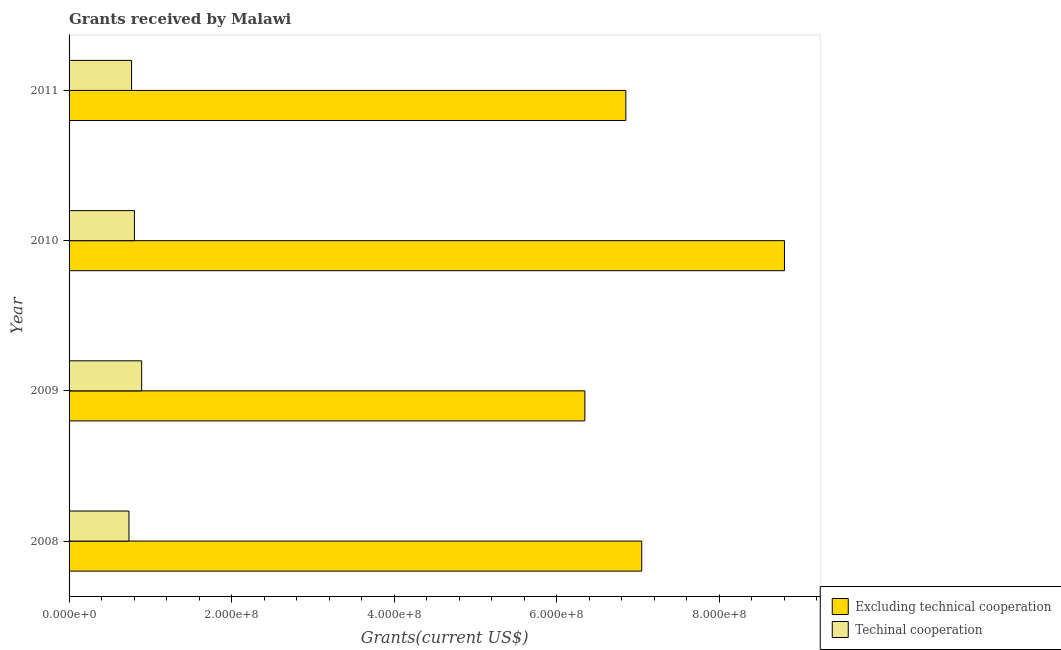How many different coloured bars are there?
Offer a very short reply. 2. How many groups of bars are there?
Keep it short and to the point. 4. Are the number of bars per tick equal to the number of legend labels?
Offer a very short reply. Yes. Are the number of bars on each tick of the Y-axis equal?
Your answer should be compact. Yes. What is the amount of grants received(excluding technical cooperation) in 2010?
Your answer should be compact. 8.80e+08. Across all years, what is the maximum amount of grants received(excluding technical cooperation)?
Your answer should be compact. 8.80e+08. Across all years, what is the minimum amount of grants received(excluding technical cooperation)?
Your response must be concise. 6.35e+08. In which year was the amount of grants received(excluding technical cooperation) maximum?
Provide a succinct answer. 2010. What is the total amount of grants received(including technical cooperation) in the graph?
Your answer should be compact. 3.20e+08. What is the difference between the amount of grants received(including technical cooperation) in 2009 and that in 2011?
Your answer should be very brief. 1.24e+07. What is the difference between the amount of grants received(excluding technical cooperation) in 2008 and the amount of grants received(including technical cooperation) in 2011?
Provide a short and direct response. 6.28e+08. What is the average amount of grants received(including technical cooperation) per year?
Give a very brief answer. 8.01e+07. In the year 2010, what is the difference between the amount of grants received(excluding technical cooperation) and amount of grants received(including technical cooperation)?
Make the answer very short. 8.00e+08. What is the ratio of the amount of grants received(including technical cooperation) in 2008 to that in 2011?
Your answer should be compact. 0.96. Is the amount of grants received(including technical cooperation) in 2008 less than that in 2010?
Provide a succinct answer. Yes. Is the difference between the amount of grants received(excluding technical cooperation) in 2010 and 2011 greater than the difference between the amount of grants received(including technical cooperation) in 2010 and 2011?
Your answer should be compact. Yes. What is the difference between the highest and the second highest amount of grants received(including technical cooperation)?
Your answer should be very brief. 8.90e+06. What is the difference between the highest and the lowest amount of grants received(including technical cooperation)?
Your answer should be very brief. 1.56e+07. Is the sum of the amount of grants received(excluding technical cooperation) in 2008 and 2010 greater than the maximum amount of grants received(including technical cooperation) across all years?
Ensure brevity in your answer.  Yes. What does the 1st bar from the top in 2011 represents?
Make the answer very short. Techinal cooperation. What does the 1st bar from the bottom in 2011 represents?
Provide a succinct answer. Excluding technical cooperation. Are all the bars in the graph horizontal?
Keep it short and to the point. Yes. Are the values on the major ticks of X-axis written in scientific E-notation?
Your answer should be very brief. Yes. Does the graph contain any zero values?
Offer a terse response. No. Where does the legend appear in the graph?
Make the answer very short. Bottom right. How many legend labels are there?
Give a very brief answer. 2. What is the title of the graph?
Keep it short and to the point. Grants received by Malawi. Does "Nitrous oxide emissions" appear as one of the legend labels in the graph?
Offer a terse response. No. What is the label or title of the X-axis?
Offer a very short reply. Grants(current US$). What is the Grants(current US$) of Excluding technical cooperation in 2008?
Ensure brevity in your answer.  7.05e+08. What is the Grants(current US$) in Techinal cooperation in 2008?
Provide a succinct answer. 7.37e+07. What is the Grants(current US$) in Excluding technical cooperation in 2009?
Provide a succinct answer. 6.35e+08. What is the Grants(current US$) in Techinal cooperation in 2009?
Offer a terse response. 8.93e+07. What is the Grants(current US$) of Excluding technical cooperation in 2010?
Offer a very short reply. 8.80e+08. What is the Grants(current US$) of Techinal cooperation in 2010?
Offer a very short reply. 8.04e+07. What is the Grants(current US$) of Excluding technical cooperation in 2011?
Your response must be concise. 6.85e+08. What is the Grants(current US$) in Techinal cooperation in 2011?
Your answer should be very brief. 7.69e+07. Across all years, what is the maximum Grants(current US$) in Excluding technical cooperation?
Provide a succinct answer. 8.80e+08. Across all years, what is the maximum Grants(current US$) of Techinal cooperation?
Ensure brevity in your answer.  8.93e+07. Across all years, what is the minimum Grants(current US$) of Excluding technical cooperation?
Your response must be concise. 6.35e+08. Across all years, what is the minimum Grants(current US$) of Techinal cooperation?
Keep it short and to the point. 7.37e+07. What is the total Grants(current US$) of Excluding technical cooperation in the graph?
Offer a terse response. 2.90e+09. What is the total Grants(current US$) of Techinal cooperation in the graph?
Make the answer very short. 3.20e+08. What is the difference between the Grants(current US$) of Excluding technical cooperation in 2008 and that in 2009?
Your answer should be very brief. 7.00e+07. What is the difference between the Grants(current US$) in Techinal cooperation in 2008 and that in 2009?
Keep it short and to the point. -1.56e+07. What is the difference between the Grants(current US$) of Excluding technical cooperation in 2008 and that in 2010?
Your answer should be very brief. -1.76e+08. What is the difference between the Grants(current US$) in Techinal cooperation in 2008 and that in 2010?
Keep it short and to the point. -6.72e+06. What is the difference between the Grants(current US$) of Excluding technical cooperation in 2008 and that in 2011?
Your response must be concise. 1.96e+07. What is the difference between the Grants(current US$) in Techinal cooperation in 2008 and that in 2011?
Make the answer very short. -3.19e+06. What is the difference between the Grants(current US$) of Excluding technical cooperation in 2009 and that in 2010?
Your response must be concise. -2.46e+08. What is the difference between the Grants(current US$) of Techinal cooperation in 2009 and that in 2010?
Offer a very short reply. 8.90e+06. What is the difference between the Grants(current US$) of Excluding technical cooperation in 2009 and that in 2011?
Provide a succinct answer. -5.04e+07. What is the difference between the Grants(current US$) of Techinal cooperation in 2009 and that in 2011?
Provide a succinct answer. 1.24e+07. What is the difference between the Grants(current US$) in Excluding technical cooperation in 2010 and that in 2011?
Your response must be concise. 1.95e+08. What is the difference between the Grants(current US$) of Techinal cooperation in 2010 and that in 2011?
Make the answer very short. 3.53e+06. What is the difference between the Grants(current US$) of Excluding technical cooperation in 2008 and the Grants(current US$) of Techinal cooperation in 2009?
Your answer should be compact. 6.15e+08. What is the difference between the Grants(current US$) in Excluding technical cooperation in 2008 and the Grants(current US$) in Techinal cooperation in 2010?
Give a very brief answer. 6.24e+08. What is the difference between the Grants(current US$) in Excluding technical cooperation in 2008 and the Grants(current US$) in Techinal cooperation in 2011?
Your response must be concise. 6.28e+08. What is the difference between the Grants(current US$) in Excluding technical cooperation in 2009 and the Grants(current US$) in Techinal cooperation in 2010?
Keep it short and to the point. 5.54e+08. What is the difference between the Grants(current US$) in Excluding technical cooperation in 2009 and the Grants(current US$) in Techinal cooperation in 2011?
Your response must be concise. 5.58e+08. What is the difference between the Grants(current US$) of Excluding technical cooperation in 2010 and the Grants(current US$) of Techinal cooperation in 2011?
Make the answer very short. 8.03e+08. What is the average Grants(current US$) in Excluding technical cooperation per year?
Your response must be concise. 7.26e+08. What is the average Grants(current US$) in Techinal cooperation per year?
Your answer should be compact. 8.01e+07. In the year 2008, what is the difference between the Grants(current US$) in Excluding technical cooperation and Grants(current US$) in Techinal cooperation?
Give a very brief answer. 6.31e+08. In the year 2009, what is the difference between the Grants(current US$) of Excluding technical cooperation and Grants(current US$) of Techinal cooperation?
Your answer should be very brief. 5.45e+08. In the year 2010, what is the difference between the Grants(current US$) in Excluding technical cooperation and Grants(current US$) in Techinal cooperation?
Your response must be concise. 8.00e+08. In the year 2011, what is the difference between the Grants(current US$) of Excluding technical cooperation and Grants(current US$) of Techinal cooperation?
Make the answer very short. 6.08e+08. What is the ratio of the Grants(current US$) in Excluding technical cooperation in 2008 to that in 2009?
Ensure brevity in your answer.  1.11. What is the ratio of the Grants(current US$) in Techinal cooperation in 2008 to that in 2009?
Provide a short and direct response. 0.83. What is the ratio of the Grants(current US$) of Excluding technical cooperation in 2008 to that in 2010?
Offer a terse response. 0.8. What is the ratio of the Grants(current US$) in Techinal cooperation in 2008 to that in 2010?
Make the answer very short. 0.92. What is the ratio of the Grants(current US$) in Excluding technical cooperation in 2008 to that in 2011?
Your response must be concise. 1.03. What is the ratio of the Grants(current US$) of Techinal cooperation in 2008 to that in 2011?
Ensure brevity in your answer.  0.96. What is the ratio of the Grants(current US$) of Excluding technical cooperation in 2009 to that in 2010?
Ensure brevity in your answer.  0.72. What is the ratio of the Grants(current US$) in Techinal cooperation in 2009 to that in 2010?
Give a very brief answer. 1.11. What is the ratio of the Grants(current US$) in Excluding technical cooperation in 2009 to that in 2011?
Ensure brevity in your answer.  0.93. What is the ratio of the Grants(current US$) of Techinal cooperation in 2009 to that in 2011?
Your answer should be very brief. 1.16. What is the ratio of the Grants(current US$) in Excluding technical cooperation in 2010 to that in 2011?
Provide a short and direct response. 1.28. What is the ratio of the Grants(current US$) of Techinal cooperation in 2010 to that in 2011?
Make the answer very short. 1.05. What is the difference between the highest and the second highest Grants(current US$) in Excluding technical cooperation?
Ensure brevity in your answer.  1.76e+08. What is the difference between the highest and the second highest Grants(current US$) in Techinal cooperation?
Provide a succinct answer. 8.90e+06. What is the difference between the highest and the lowest Grants(current US$) in Excluding technical cooperation?
Provide a succinct answer. 2.46e+08. What is the difference between the highest and the lowest Grants(current US$) of Techinal cooperation?
Provide a short and direct response. 1.56e+07. 